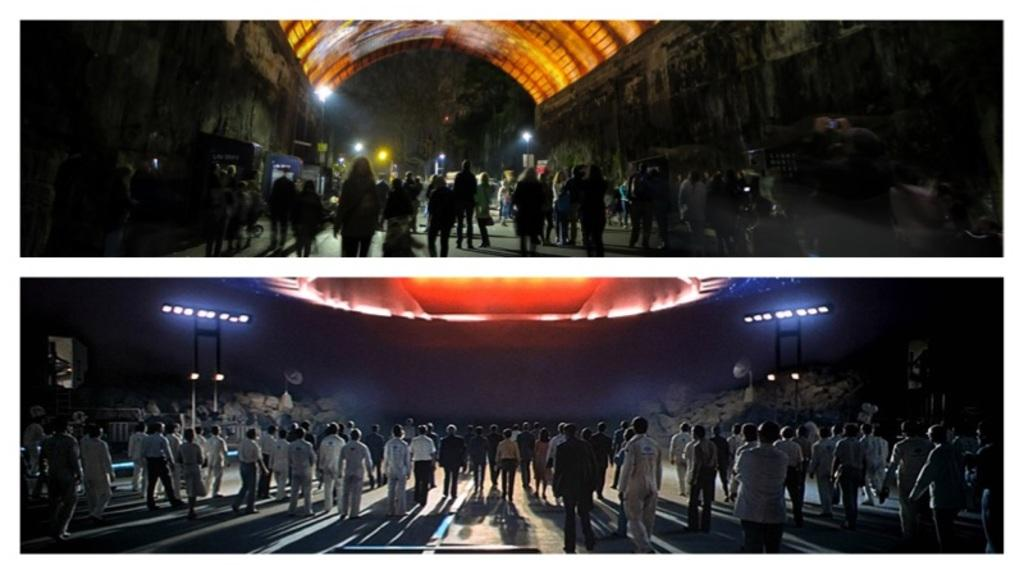What is the composition of the image? The image contains a collage of two pictures. Can you describe the subjects in the image? There are people visible in the image. What additional elements are present in the image? There are lights around the people in the image. What direction does the afterthought take in the image? There is no afterthought present in the image, as it is a collage of two pictures featuring people with lights around them. 